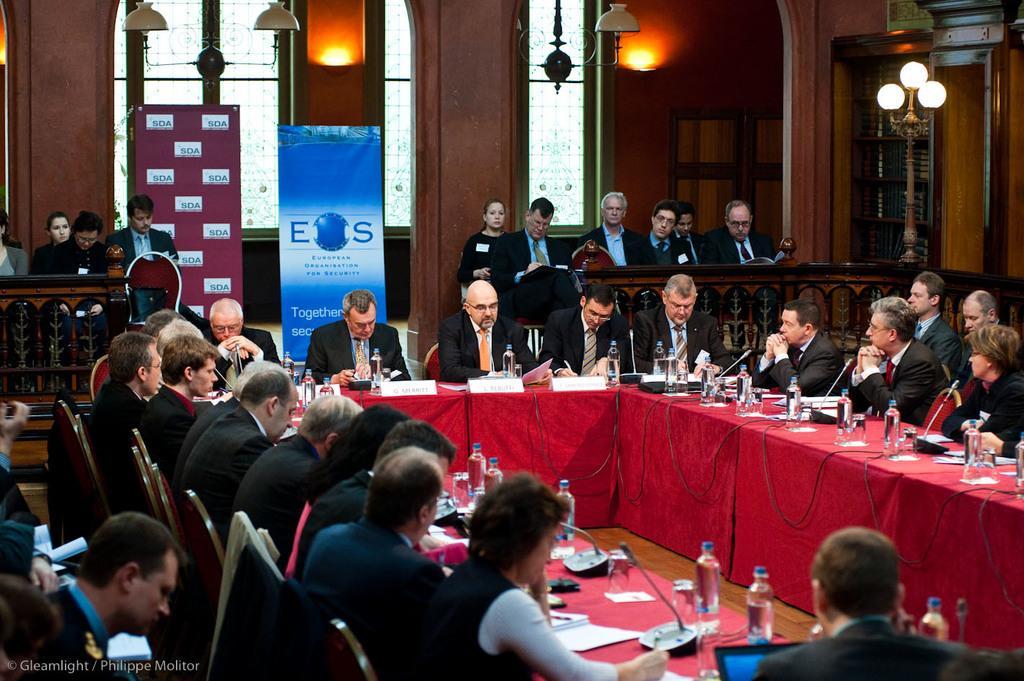Could you give a brief overview of what you see in this image? In the image we can see there are people who are sitting on chair and few people are standing at the back and on the table there are water bottles and paper. 